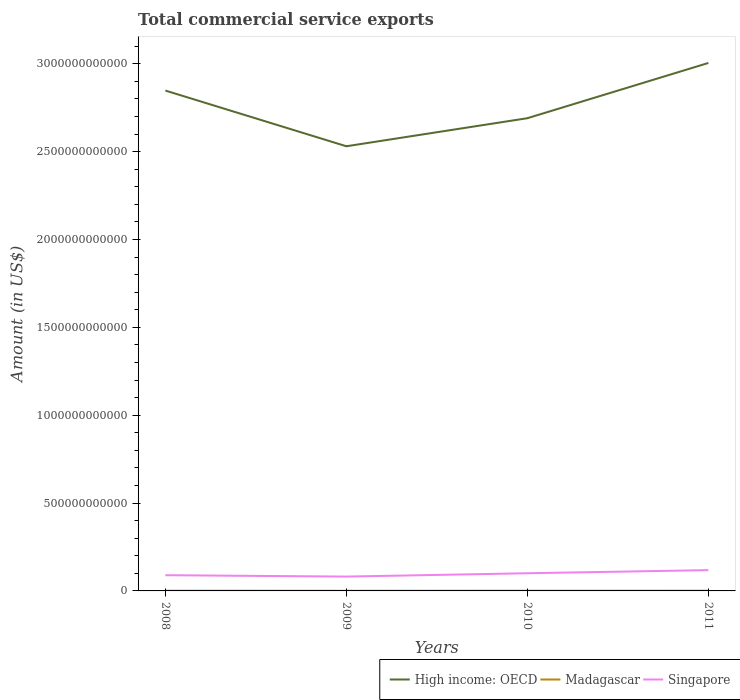How many different coloured lines are there?
Keep it short and to the point. 3. Does the line corresponding to High income: OECD intersect with the line corresponding to Madagascar?
Keep it short and to the point. No. Is the number of lines equal to the number of legend labels?
Make the answer very short. Yes. Across all years, what is the maximum total commercial service exports in Madagascar?
Keep it short and to the point. 7.36e+08. What is the total total commercial service exports in Singapore in the graph?
Your answer should be compact. 7.83e+09. What is the difference between the highest and the second highest total commercial service exports in High income: OECD?
Offer a very short reply. 4.74e+11. What is the difference between the highest and the lowest total commercial service exports in High income: OECD?
Make the answer very short. 2. Is the total commercial service exports in High income: OECD strictly greater than the total commercial service exports in Singapore over the years?
Offer a terse response. No. How many lines are there?
Offer a very short reply. 3. How many years are there in the graph?
Ensure brevity in your answer.  4. What is the difference between two consecutive major ticks on the Y-axis?
Keep it short and to the point. 5.00e+11. Are the values on the major ticks of Y-axis written in scientific E-notation?
Provide a short and direct response. No. Does the graph contain grids?
Make the answer very short. No. How many legend labels are there?
Provide a short and direct response. 3. How are the legend labels stacked?
Offer a very short reply. Horizontal. What is the title of the graph?
Your answer should be very brief. Total commercial service exports. Does "Mauritius" appear as one of the legend labels in the graph?
Your answer should be compact. No. What is the label or title of the X-axis?
Offer a very short reply. Years. What is the Amount (in US$) of High income: OECD in 2008?
Ensure brevity in your answer.  2.85e+12. What is the Amount (in US$) of Madagascar in 2008?
Your answer should be compact. 1.10e+09. What is the Amount (in US$) of Singapore in 2008?
Give a very brief answer. 8.94e+1. What is the Amount (in US$) of High income: OECD in 2009?
Keep it short and to the point. 2.53e+12. What is the Amount (in US$) in Madagascar in 2009?
Your answer should be very brief. 7.36e+08. What is the Amount (in US$) in Singapore in 2009?
Make the answer very short. 8.16e+1. What is the Amount (in US$) of High income: OECD in 2010?
Provide a succinct answer. 2.69e+12. What is the Amount (in US$) of Madagascar in 2010?
Provide a succinct answer. 9.61e+08. What is the Amount (in US$) in Singapore in 2010?
Provide a succinct answer. 1.01e+11. What is the Amount (in US$) of High income: OECD in 2011?
Provide a short and direct response. 3.00e+12. What is the Amount (in US$) of Madagascar in 2011?
Provide a short and direct response. 1.16e+09. What is the Amount (in US$) of Singapore in 2011?
Ensure brevity in your answer.  1.18e+11. Across all years, what is the maximum Amount (in US$) in High income: OECD?
Your answer should be compact. 3.00e+12. Across all years, what is the maximum Amount (in US$) in Madagascar?
Ensure brevity in your answer.  1.16e+09. Across all years, what is the maximum Amount (in US$) of Singapore?
Offer a very short reply. 1.18e+11. Across all years, what is the minimum Amount (in US$) of High income: OECD?
Give a very brief answer. 2.53e+12. Across all years, what is the minimum Amount (in US$) in Madagascar?
Your answer should be very brief. 7.36e+08. Across all years, what is the minimum Amount (in US$) of Singapore?
Offer a very short reply. 8.16e+1. What is the total Amount (in US$) of High income: OECD in the graph?
Provide a succinct answer. 1.11e+13. What is the total Amount (in US$) in Madagascar in the graph?
Provide a succinct answer. 3.96e+09. What is the total Amount (in US$) of Singapore in the graph?
Provide a succinct answer. 3.90e+11. What is the difference between the Amount (in US$) of High income: OECD in 2008 and that in 2009?
Give a very brief answer. 3.17e+11. What is the difference between the Amount (in US$) of Madagascar in 2008 and that in 2009?
Offer a terse response. 3.65e+08. What is the difference between the Amount (in US$) of Singapore in 2008 and that in 2009?
Your answer should be very brief. 7.83e+09. What is the difference between the Amount (in US$) of High income: OECD in 2008 and that in 2010?
Offer a terse response. 1.57e+11. What is the difference between the Amount (in US$) in Madagascar in 2008 and that in 2010?
Give a very brief answer. 1.40e+08. What is the difference between the Amount (in US$) in Singapore in 2008 and that in 2010?
Offer a terse response. -1.12e+1. What is the difference between the Amount (in US$) in High income: OECD in 2008 and that in 2011?
Give a very brief answer. -1.57e+11. What is the difference between the Amount (in US$) of Madagascar in 2008 and that in 2011?
Keep it short and to the point. -5.88e+07. What is the difference between the Amount (in US$) in Singapore in 2008 and that in 2011?
Your answer should be very brief. -2.89e+1. What is the difference between the Amount (in US$) in High income: OECD in 2009 and that in 2010?
Keep it short and to the point. -1.60e+11. What is the difference between the Amount (in US$) in Madagascar in 2009 and that in 2010?
Your response must be concise. -2.25e+08. What is the difference between the Amount (in US$) of Singapore in 2009 and that in 2010?
Make the answer very short. -1.90e+1. What is the difference between the Amount (in US$) in High income: OECD in 2009 and that in 2011?
Ensure brevity in your answer.  -4.74e+11. What is the difference between the Amount (in US$) in Madagascar in 2009 and that in 2011?
Offer a terse response. -4.24e+08. What is the difference between the Amount (in US$) in Singapore in 2009 and that in 2011?
Provide a succinct answer. -3.67e+1. What is the difference between the Amount (in US$) of High income: OECD in 2010 and that in 2011?
Keep it short and to the point. -3.14e+11. What is the difference between the Amount (in US$) in Madagascar in 2010 and that in 2011?
Ensure brevity in your answer.  -1.99e+08. What is the difference between the Amount (in US$) in Singapore in 2010 and that in 2011?
Provide a succinct answer. -1.77e+1. What is the difference between the Amount (in US$) in High income: OECD in 2008 and the Amount (in US$) in Madagascar in 2009?
Your response must be concise. 2.85e+12. What is the difference between the Amount (in US$) of High income: OECD in 2008 and the Amount (in US$) of Singapore in 2009?
Your answer should be very brief. 2.77e+12. What is the difference between the Amount (in US$) of Madagascar in 2008 and the Amount (in US$) of Singapore in 2009?
Your response must be concise. -8.05e+1. What is the difference between the Amount (in US$) in High income: OECD in 2008 and the Amount (in US$) in Madagascar in 2010?
Ensure brevity in your answer.  2.85e+12. What is the difference between the Amount (in US$) of High income: OECD in 2008 and the Amount (in US$) of Singapore in 2010?
Provide a succinct answer. 2.75e+12. What is the difference between the Amount (in US$) of Madagascar in 2008 and the Amount (in US$) of Singapore in 2010?
Ensure brevity in your answer.  -9.95e+1. What is the difference between the Amount (in US$) in High income: OECD in 2008 and the Amount (in US$) in Madagascar in 2011?
Offer a very short reply. 2.85e+12. What is the difference between the Amount (in US$) in High income: OECD in 2008 and the Amount (in US$) in Singapore in 2011?
Keep it short and to the point. 2.73e+12. What is the difference between the Amount (in US$) of Madagascar in 2008 and the Amount (in US$) of Singapore in 2011?
Your answer should be very brief. -1.17e+11. What is the difference between the Amount (in US$) in High income: OECD in 2009 and the Amount (in US$) in Madagascar in 2010?
Provide a succinct answer. 2.53e+12. What is the difference between the Amount (in US$) in High income: OECD in 2009 and the Amount (in US$) in Singapore in 2010?
Provide a succinct answer. 2.43e+12. What is the difference between the Amount (in US$) in Madagascar in 2009 and the Amount (in US$) in Singapore in 2010?
Ensure brevity in your answer.  -9.98e+1. What is the difference between the Amount (in US$) of High income: OECD in 2009 and the Amount (in US$) of Madagascar in 2011?
Provide a succinct answer. 2.53e+12. What is the difference between the Amount (in US$) of High income: OECD in 2009 and the Amount (in US$) of Singapore in 2011?
Your answer should be compact. 2.41e+12. What is the difference between the Amount (in US$) of Madagascar in 2009 and the Amount (in US$) of Singapore in 2011?
Offer a terse response. -1.18e+11. What is the difference between the Amount (in US$) of High income: OECD in 2010 and the Amount (in US$) of Madagascar in 2011?
Your response must be concise. 2.69e+12. What is the difference between the Amount (in US$) of High income: OECD in 2010 and the Amount (in US$) of Singapore in 2011?
Offer a very short reply. 2.57e+12. What is the difference between the Amount (in US$) of Madagascar in 2010 and the Amount (in US$) of Singapore in 2011?
Ensure brevity in your answer.  -1.17e+11. What is the average Amount (in US$) in High income: OECD per year?
Make the answer very short. 2.77e+12. What is the average Amount (in US$) of Madagascar per year?
Provide a short and direct response. 9.90e+08. What is the average Amount (in US$) of Singapore per year?
Give a very brief answer. 9.75e+1. In the year 2008, what is the difference between the Amount (in US$) in High income: OECD and Amount (in US$) in Madagascar?
Make the answer very short. 2.85e+12. In the year 2008, what is the difference between the Amount (in US$) of High income: OECD and Amount (in US$) of Singapore?
Your answer should be compact. 2.76e+12. In the year 2008, what is the difference between the Amount (in US$) in Madagascar and Amount (in US$) in Singapore?
Ensure brevity in your answer.  -8.83e+1. In the year 2009, what is the difference between the Amount (in US$) of High income: OECD and Amount (in US$) of Madagascar?
Provide a succinct answer. 2.53e+12. In the year 2009, what is the difference between the Amount (in US$) of High income: OECD and Amount (in US$) of Singapore?
Your response must be concise. 2.45e+12. In the year 2009, what is the difference between the Amount (in US$) in Madagascar and Amount (in US$) in Singapore?
Offer a very short reply. -8.09e+1. In the year 2010, what is the difference between the Amount (in US$) in High income: OECD and Amount (in US$) in Madagascar?
Your response must be concise. 2.69e+12. In the year 2010, what is the difference between the Amount (in US$) in High income: OECD and Amount (in US$) in Singapore?
Your response must be concise. 2.59e+12. In the year 2010, what is the difference between the Amount (in US$) of Madagascar and Amount (in US$) of Singapore?
Provide a short and direct response. -9.96e+1. In the year 2011, what is the difference between the Amount (in US$) in High income: OECD and Amount (in US$) in Madagascar?
Provide a succinct answer. 3.00e+12. In the year 2011, what is the difference between the Amount (in US$) in High income: OECD and Amount (in US$) in Singapore?
Your answer should be very brief. 2.89e+12. In the year 2011, what is the difference between the Amount (in US$) in Madagascar and Amount (in US$) in Singapore?
Your answer should be compact. -1.17e+11. What is the ratio of the Amount (in US$) in High income: OECD in 2008 to that in 2009?
Make the answer very short. 1.13. What is the ratio of the Amount (in US$) in Madagascar in 2008 to that in 2009?
Your answer should be compact. 1.5. What is the ratio of the Amount (in US$) in Singapore in 2008 to that in 2009?
Ensure brevity in your answer.  1.1. What is the ratio of the Amount (in US$) in High income: OECD in 2008 to that in 2010?
Give a very brief answer. 1.06. What is the ratio of the Amount (in US$) in Madagascar in 2008 to that in 2010?
Offer a terse response. 1.15. What is the ratio of the Amount (in US$) in Singapore in 2008 to that in 2010?
Ensure brevity in your answer.  0.89. What is the ratio of the Amount (in US$) of High income: OECD in 2008 to that in 2011?
Ensure brevity in your answer.  0.95. What is the ratio of the Amount (in US$) in Madagascar in 2008 to that in 2011?
Provide a succinct answer. 0.95. What is the ratio of the Amount (in US$) in Singapore in 2008 to that in 2011?
Provide a succinct answer. 0.76. What is the ratio of the Amount (in US$) of High income: OECD in 2009 to that in 2010?
Give a very brief answer. 0.94. What is the ratio of the Amount (in US$) of Madagascar in 2009 to that in 2010?
Your answer should be compact. 0.77. What is the ratio of the Amount (in US$) of Singapore in 2009 to that in 2010?
Make the answer very short. 0.81. What is the ratio of the Amount (in US$) of High income: OECD in 2009 to that in 2011?
Ensure brevity in your answer.  0.84. What is the ratio of the Amount (in US$) of Madagascar in 2009 to that in 2011?
Keep it short and to the point. 0.63. What is the ratio of the Amount (in US$) of Singapore in 2009 to that in 2011?
Provide a short and direct response. 0.69. What is the ratio of the Amount (in US$) in High income: OECD in 2010 to that in 2011?
Make the answer very short. 0.9. What is the ratio of the Amount (in US$) of Madagascar in 2010 to that in 2011?
Offer a very short reply. 0.83. What is the ratio of the Amount (in US$) of Singapore in 2010 to that in 2011?
Make the answer very short. 0.85. What is the difference between the highest and the second highest Amount (in US$) of High income: OECD?
Your response must be concise. 1.57e+11. What is the difference between the highest and the second highest Amount (in US$) in Madagascar?
Your response must be concise. 5.88e+07. What is the difference between the highest and the second highest Amount (in US$) of Singapore?
Offer a very short reply. 1.77e+1. What is the difference between the highest and the lowest Amount (in US$) in High income: OECD?
Ensure brevity in your answer.  4.74e+11. What is the difference between the highest and the lowest Amount (in US$) in Madagascar?
Your answer should be very brief. 4.24e+08. What is the difference between the highest and the lowest Amount (in US$) in Singapore?
Your response must be concise. 3.67e+1. 